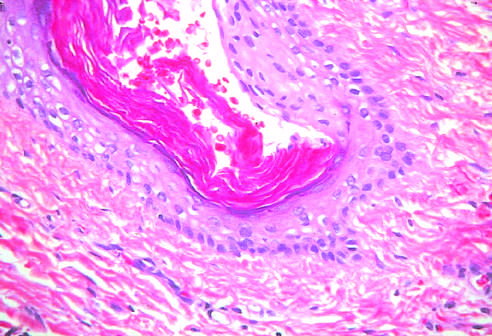do two small pulmonary arterioles contain mature cells from endodermal, mesodermal, and ectodermal lines?
Answer the question using a single word or phrase. No 